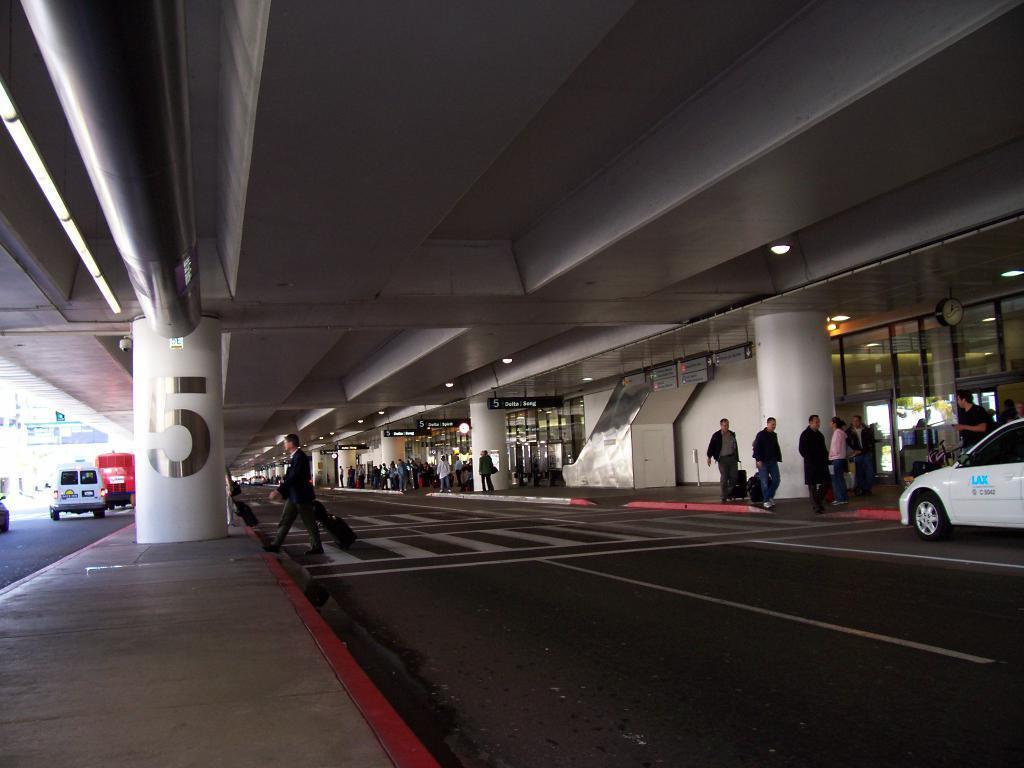Can you describe this image briefly? In this image we can see there are people walking and holding bags. And there are vehicles on the road. There is a building with doors and window. And there are pillars and boards. At the top there is a ceiling with lights. 